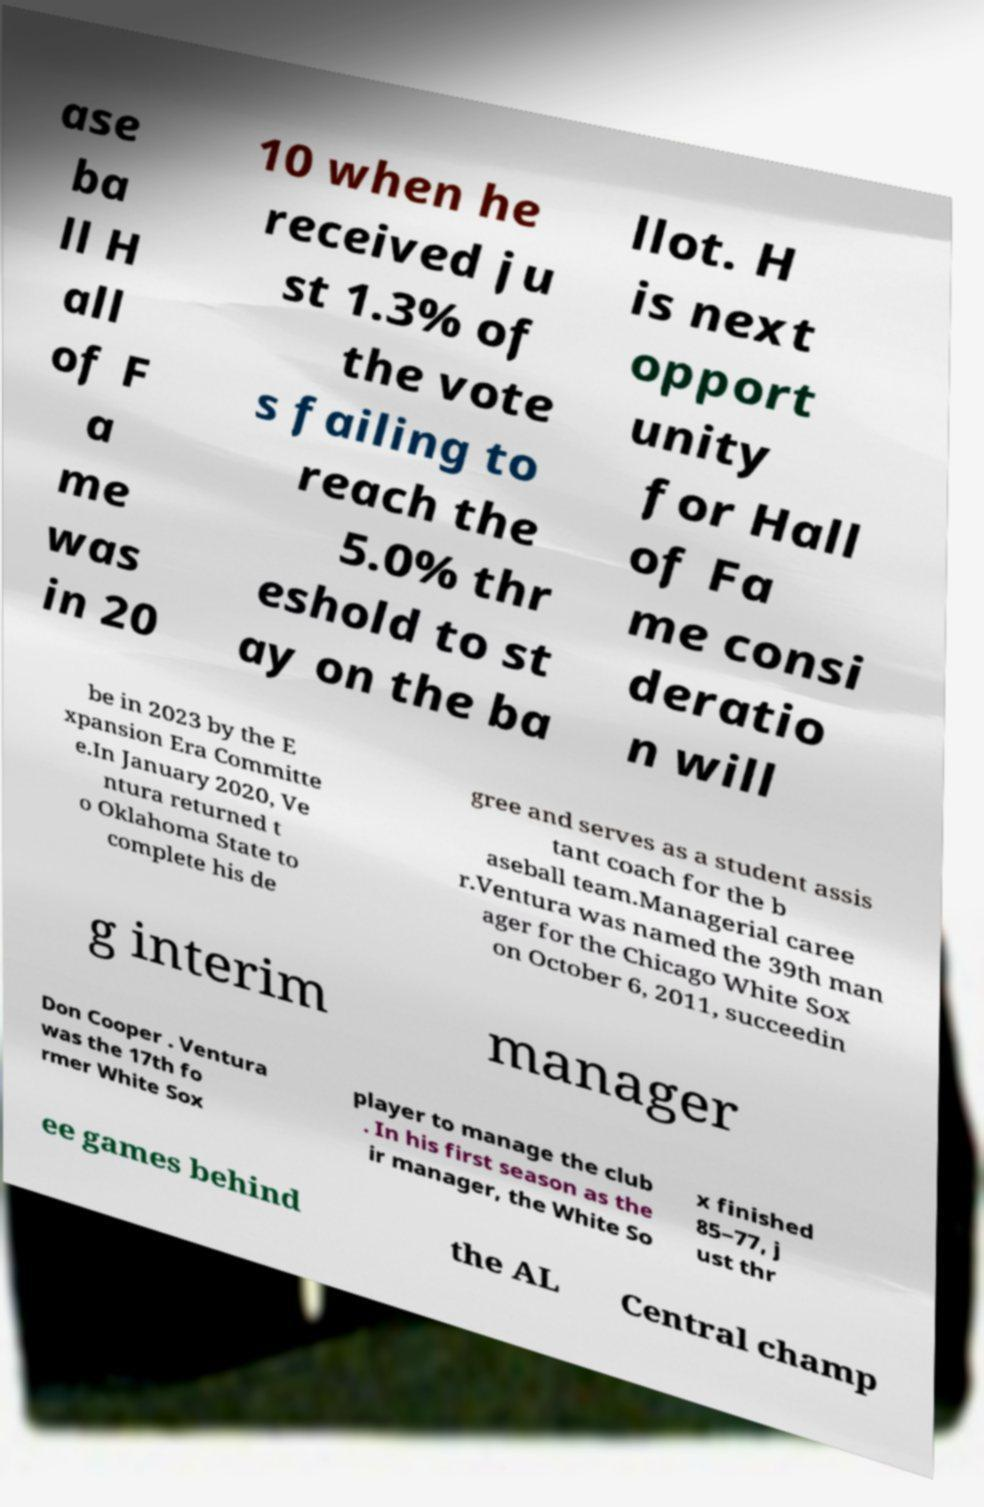Please read and relay the text visible in this image. What does it say? ase ba ll H all of F a me was in 20 10 when he received ju st 1.3% of the vote s failing to reach the 5.0% thr eshold to st ay on the ba llot. H is next opport unity for Hall of Fa me consi deratio n will be in 2023 by the E xpansion Era Committe e.In January 2020, Ve ntura returned t o Oklahoma State to complete his de gree and serves as a student assis tant coach for the b aseball team.Managerial caree r.Ventura was named the 39th man ager for the Chicago White Sox on October 6, 2011, succeedin g interim manager Don Cooper . Ventura was the 17th fo rmer White Sox player to manage the club . In his first season as the ir manager, the White So x finished 85–77, j ust thr ee games behind the AL Central champ 